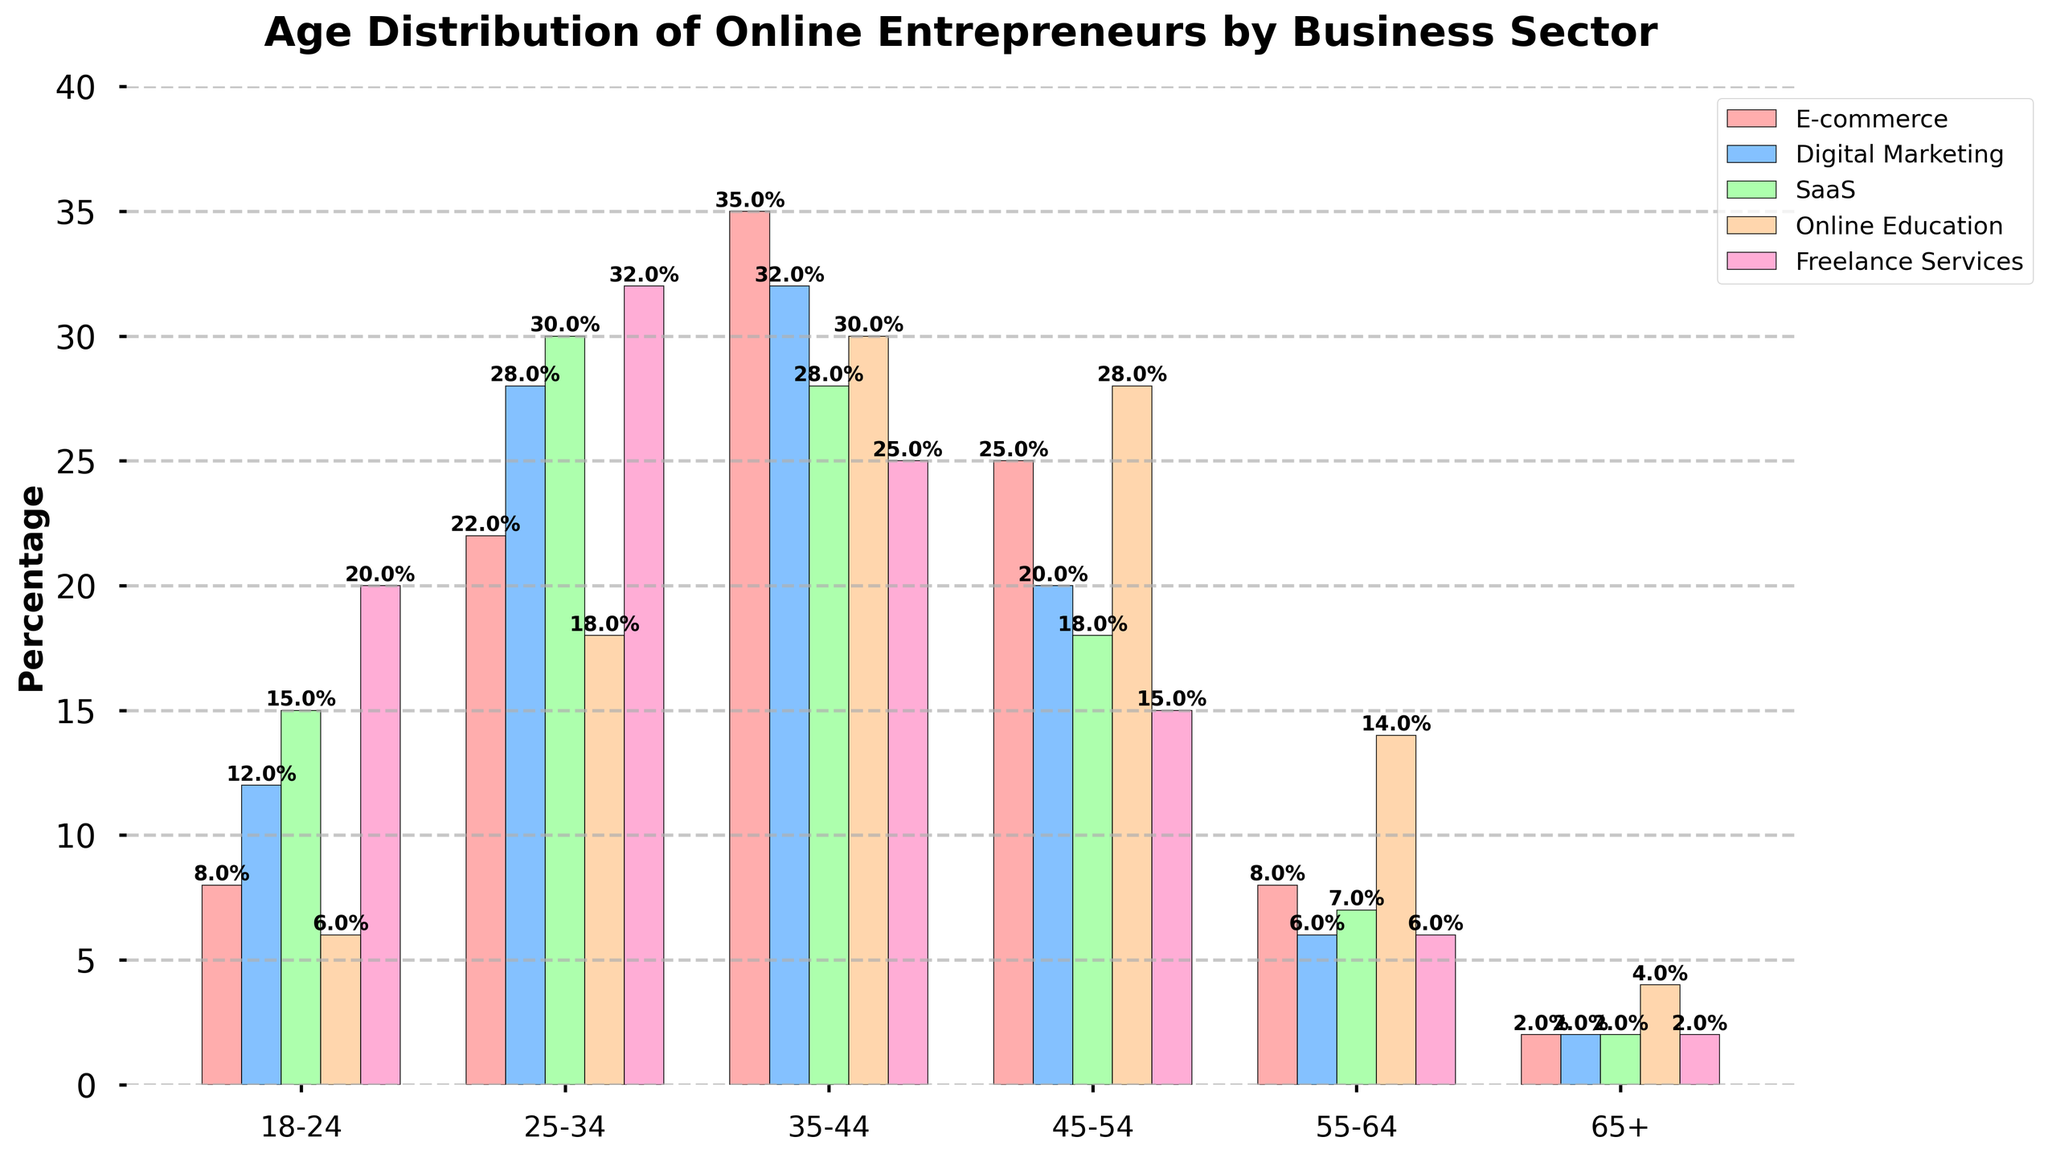Which age group has the highest percentage in E-commerce? To find the age group with the highest percentage in E-commerce, look at the height of the bars labeled "E-commerce" and compare them. The 35-44 age group has the highest bar at 35%.
Answer: 35-44 Which business sector has the highest percentage of entrepreneurs aged 25-34? To determine this, compare the heights of the bars for the 25-34 age group across all business sectors. The Freelance Services sector has the highest percentage at 32%.
Answer: Freelance Services What is the difference in percentage between the youngest (18-24) and oldest (65+) age groups in the Online Education sector? Find the values for the age groups 18-24 and 65+ in the Online Education sector, which are 6% and 4%, respectively. Calculate the difference: 6% - 4% = 2%.
Answer: 2% Which business sector has the most evenly distributed age groups? Examine the bars across all age groups within each sector. The Online Education sector shows a relatively even distribution with percentages of 6%, 18%, 30%, 28%, 14%, and 4%.
Answer: Online Education In which age group is the SaaS sector the most popular, and by how much does it exceed the popularity in the 55-64 age group? The 25-34 age group is the most popular for the SaaS sector with 30%. For the 55-64 age group, it is 7%. Calculate the difference: 30% - 7% = 23%.
Answer: 25-34, 23% Which two age groups collectively make up the majority percentage in Digital Marketing? Identify and sum the highest two percentages in Digital Marketing: The 25-34 (28%) and 35-44 (32%) age groups. Add them together: 28% + 32% = 60%.
Answer: 25-34 and 35-44, 60% What is the combined percentage of entrepreneurs aged 45-54 across all sectors? Sum the percentages of the 45-54 age group in each sector: 25% (E-commerce) + 20% (Digital Marketing) + 18% (SaaS) + 28% (Online Education) + 15% (Freelance Services) = 106%.
Answer: 106% How does the percentage of 18-24-year-old entrepreneurs in Freelance Services compare to that in E-commerce? Look at the bars for the 18-24 age group in Freelance Services and E-commerce. Freelance Services is at 20%, and E-commerce is at 8%. Thus, Freelance Services has a higher percentage: 20% - 8% = 12%.
Answer: Freelance Services is higher by 12% In which sector is the 45-54 age group least represented, and what is its percentage? Compare the heights of the bars for the 45-54 age group across all sectors. SaaS has the lowest representation at 18%.
Answer: SaaS, 18% What is the average percentage of entrepreneurs aged 35-44 across all sectors? Add the percentages of the 35-44 age group across all sectors and divide by the number of sectors: (35% + 32% + 28% + 30% + 25%) / 5 = 150% / 5 = 30%.
Answer: 30% 